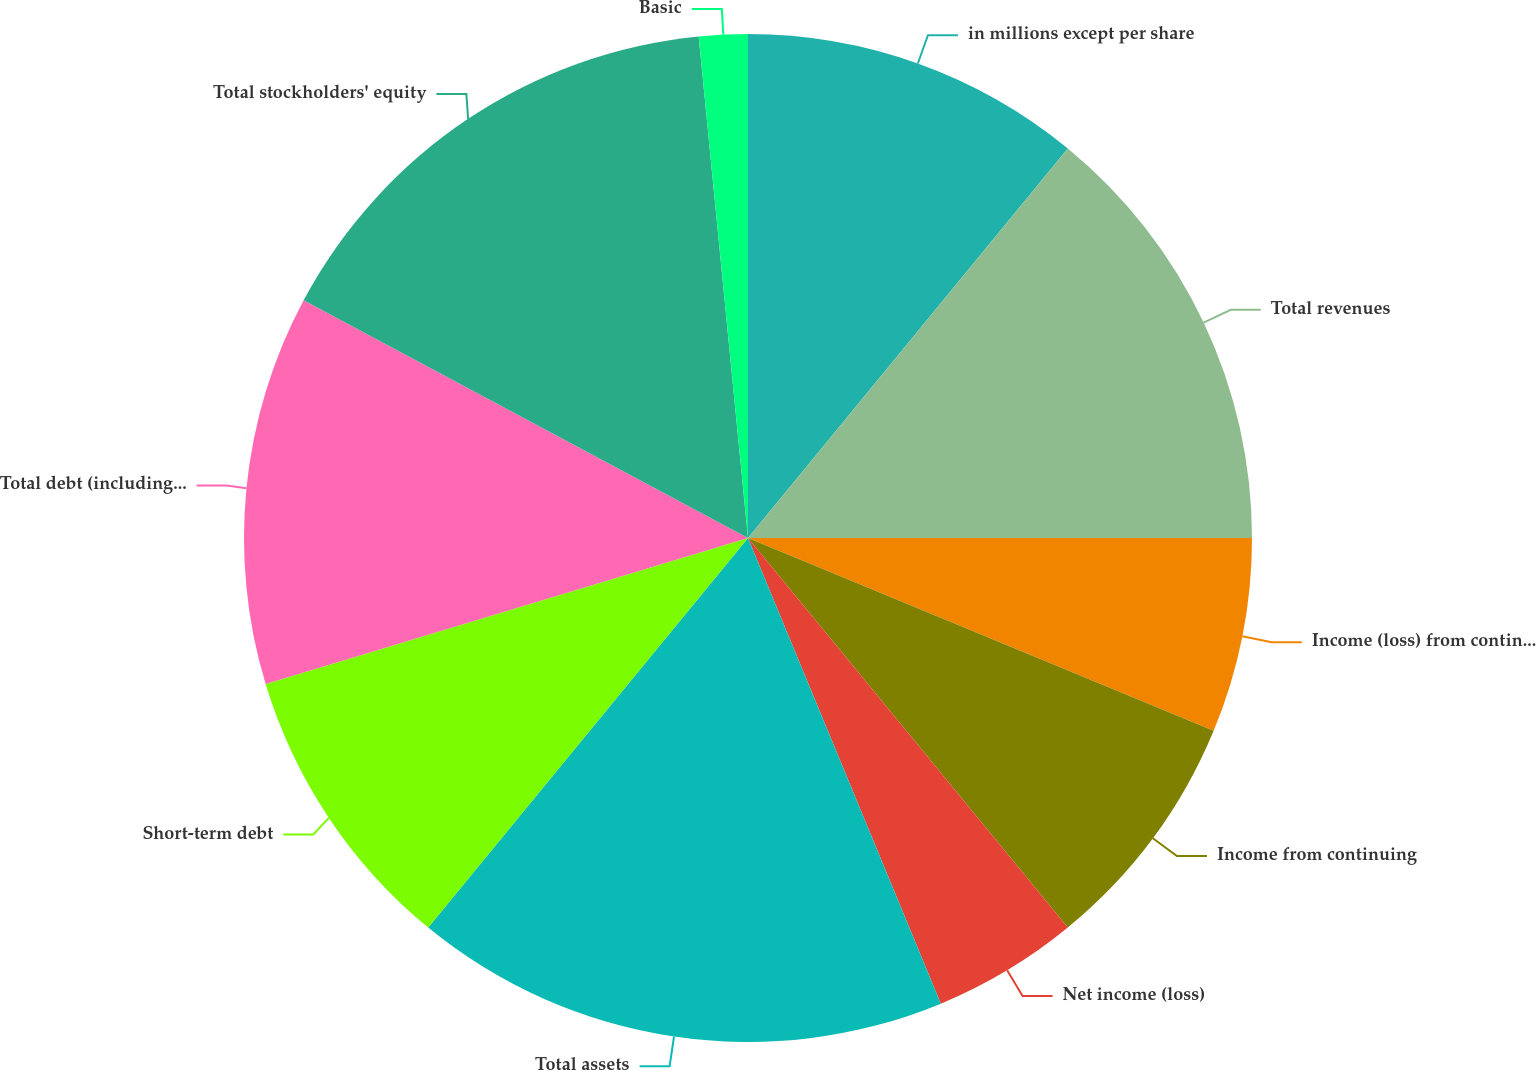Convert chart. <chart><loc_0><loc_0><loc_500><loc_500><pie_chart><fcel>in millions except per share<fcel>Total revenues<fcel>Income (loss) from continuing<fcel>Income from continuing<fcel>Net income (loss)<fcel>Total assets<fcel>Short-term debt<fcel>Total debt (including capital<fcel>Total stockholders' equity<fcel>Basic<nl><fcel>10.94%<fcel>14.06%<fcel>6.25%<fcel>7.81%<fcel>4.69%<fcel>17.19%<fcel>9.38%<fcel>12.5%<fcel>15.62%<fcel>1.56%<nl></chart> 